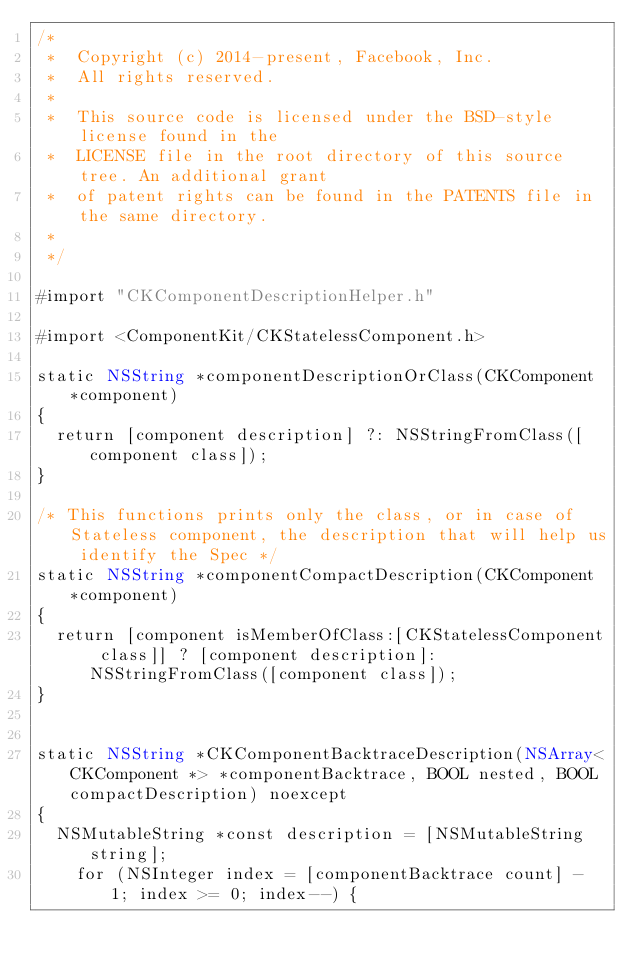<code> <loc_0><loc_0><loc_500><loc_500><_ObjectiveC_>/*
 *  Copyright (c) 2014-present, Facebook, Inc.
 *  All rights reserved.
 *
 *  This source code is licensed under the BSD-style license found in the
 *  LICENSE file in the root directory of this source tree. An additional grant
 *  of patent rights can be found in the PATENTS file in the same directory.
 *
 */

#import "CKComponentDescriptionHelper.h"

#import <ComponentKit/CKStatelessComponent.h>

static NSString *componentDescriptionOrClass(CKComponent *component)
{
  return [component description] ?: NSStringFromClass([component class]);
}

/* This functions prints only the class, or in case of Stateless component, the description that will help us identify the Spec */
static NSString *componentCompactDescription(CKComponent *component)
{
  return [component isMemberOfClass:[CKStatelessComponent class]] ? [component description]: NSStringFromClass([component class]);
}


static NSString *CKComponentBacktraceDescription(NSArray<CKComponent *> *componentBacktrace, BOOL nested, BOOL compactDescription) noexcept
{
  NSMutableString *const description = [NSMutableString string];
    for (NSInteger index = [componentBacktrace count] - 1; index >= 0; index--) {</code> 